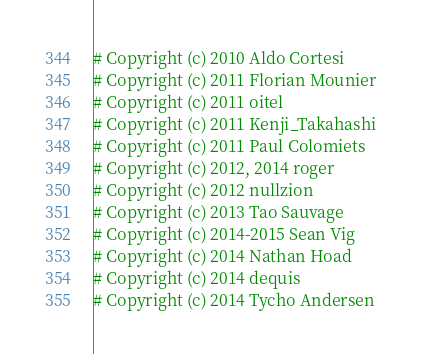Convert code to text. <code><loc_0><loc_0><loc_500><loc_500><_Python_># Copyright (c) 2010 Aldo Cortesi
# Copyright (c) 2011 Florian Mounier
# Copyright (c) 2011 oitel
# Copyright (c) 2011 Kenji_Takahashi
# Copyright (c) 2011 Paul Colomiets
# Copyright (c) 2012, 2014 roger
# Copyright (c) 2012 nullzion
# Copyright (c) 2013 Tao Sauvage
# Copyright (c) 2014-2015 Sean Vig
# Copyright (c) 2014 Nathan Hoad
# Copyright (c) 2014 dequis
# Copyright (c) 2014 Tycho Andersen</code> 